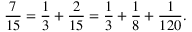<formula> <loc_0><loc_0><loc_500><loc_500>{ \frac { 7 } { 1 5 } } = { \frac { 1 } { 3 } } + { \frac { 2 } { 1 5 } } = { \frac { 1 } { 3 } } + { \frac { 1 } { 8 } } + { \frac { 1 } { 1 2 0 } } .</formula> 